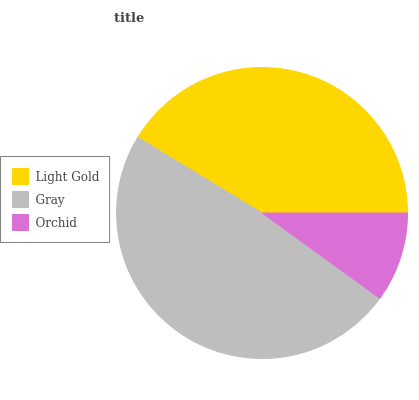Is Orchid the minimum?
Answer yes or no. Yes. Is Gray the maximum?
Answer yes or no. Yes. Is Gray the minimum?
Answer yes or no. No. Is Orchid the maximum?
Answer yes or no. No. Is Gray greater than Orchid?
Answer yes or no. Yes. Is Orchid less than Gray?
Answer yes or no. Yes. Is Orchid greater than Gray?
Answer yes or no. No. Is Gray less than Orchid?
Answer yes or no. No. Is Light Gold the high median?
Answer yes or no. Yes. Is Light Gold the low median?
Answer yes or no. Yes. Is Gray the high median?
Answer yes or no. No. Is Gray the low median?
Answer yes or no. No. 